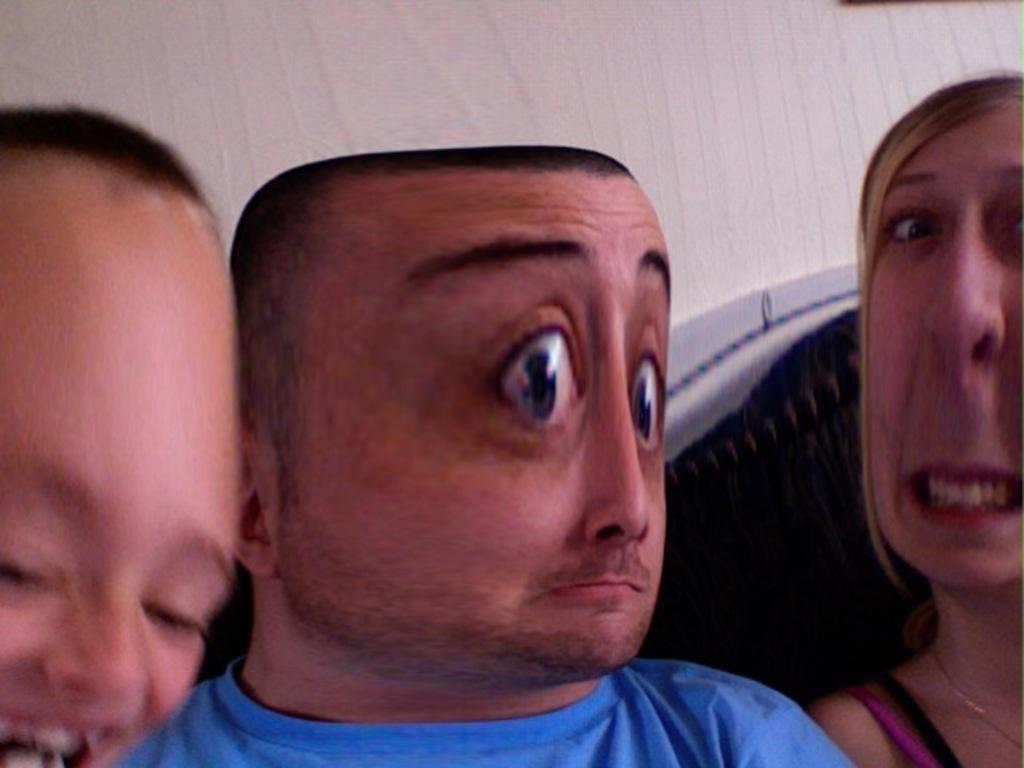How many people are present in the image? There are three people in the image. Can you describe the facial expression of one of the people? One person is smiling on the left side. What can be seen in the background of the image? There is a wall in the background of the image. What type of curtain can be seen hanging from the roof in the image? There is no curtain or roof present in the image; it only features three people and a wall in the background. 